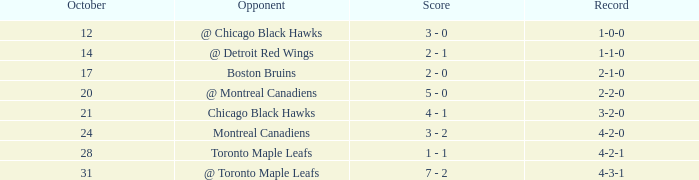What was the score of the game after game 6 on October 28? 1 - 1. 